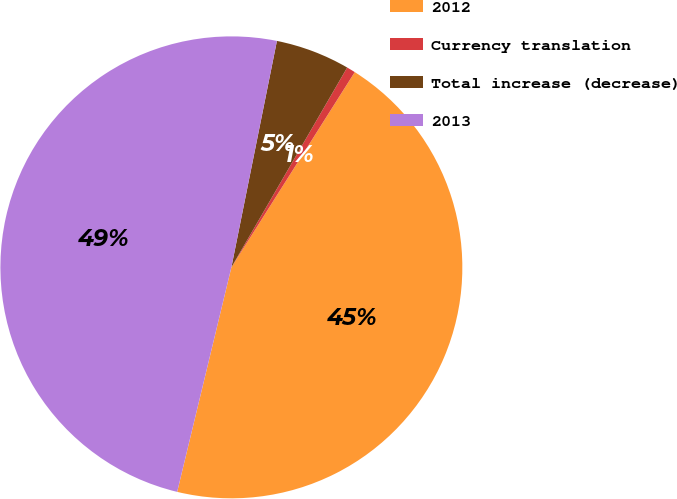<chart> <loc_0><loc_0><loc_500><loc_500><pie_chart><fcel>2012<fcel>Currency translation<fcel>Total increase (decrease)<fcel>2013<nl><fcel>44.8%<fcel>0.61%<fcel>5.2%<fcel>49.39%<nl></chart> 